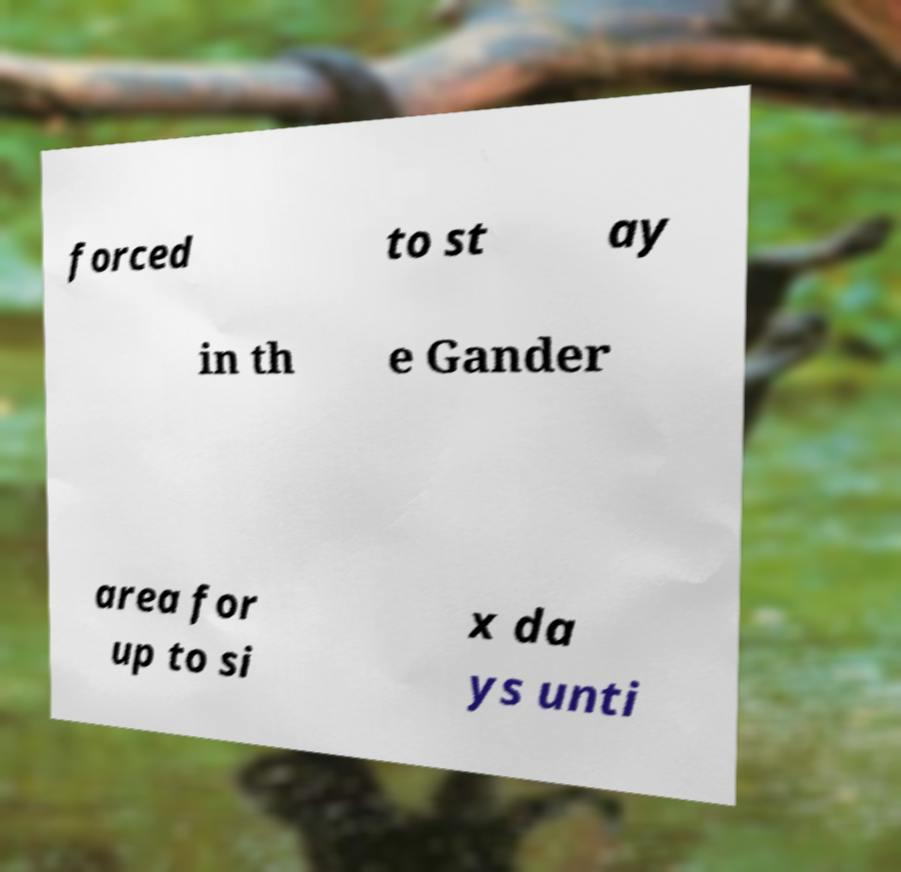Can you read and provide the text displayed in the image?This photo seems to have some interesting text. Can you extract and type it out for me? forced to st ay in th e Gander area for up to si x da ys unti 